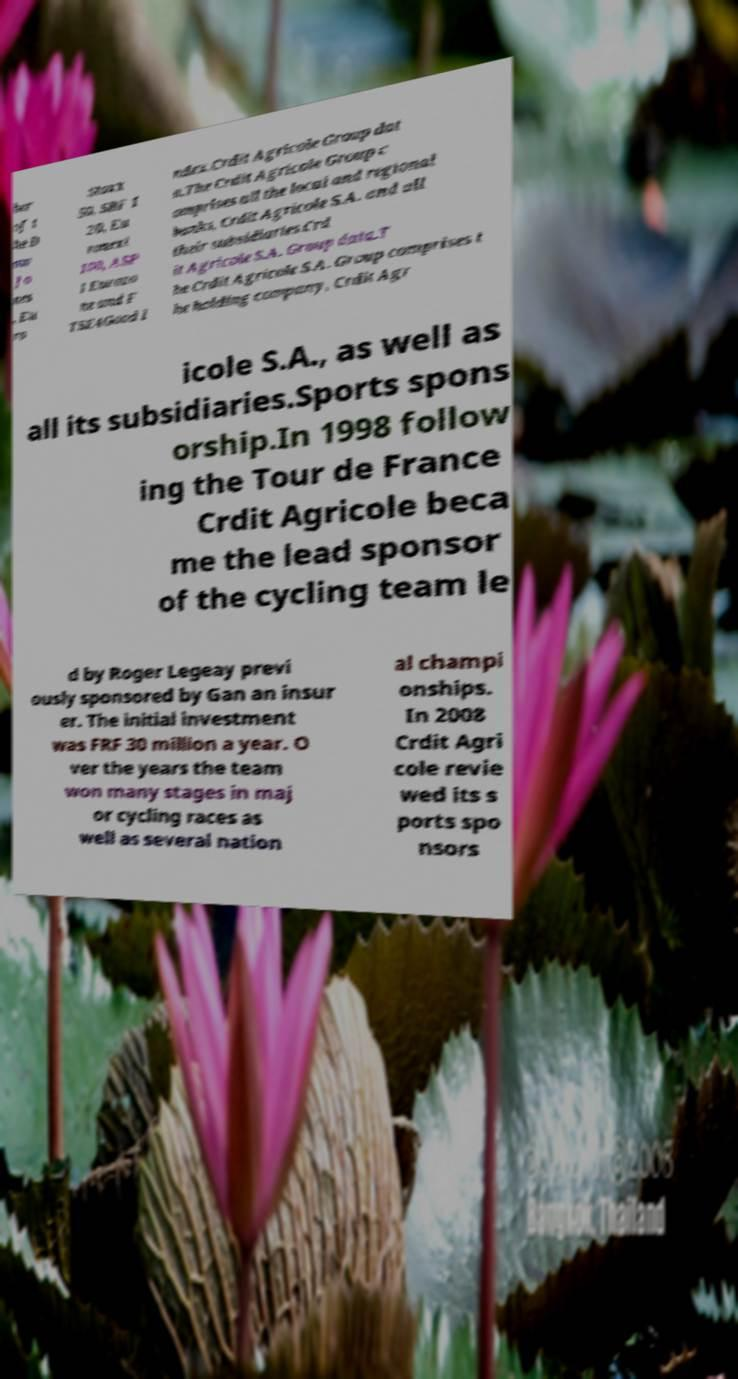Please read and relay the text visible in this image. What does it say? ber of t he D ow Jo nes , Eu ro Stoxx 50, SBF 1 20, Eu ronext 100, ASP I Eurozo ne and F TSE4Good I ndex.Crdit Agricole Group dat a.The Crdit Agricole Group c omprises all the local and regional banks, Crdit Agricole S.A. and all their subsidiaries.Crd it Agricole S.A. Group data.T he Crdit Agricole S.A. Group comprises t he holding company, Crdit Agr icole S.A., as well as all its subsidiaries.Sports spons orship.In 1998 follow ing the Tour de France Crdit Agricole beca me the lead sponsor of the cycling team le d by Roger Legeay previ ously sponsored by Gan an insur er. The initial investment was FRF 30 million a year. O ver the years the team won many stages in maj or cycling races as well as several nation al champi onships. In 2008 Crdit Agri cole revie wed its s ports spo nsors 